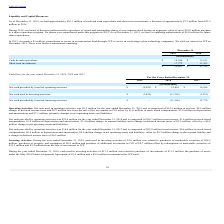From Finjan Holding's financial document, What is the respective value of purchases relating to the purchase of investments and the purchase of assets under the May 2018 Patent Assignment Agreement? The document shows two values: $11.3 million and $1.0 million. From the document: "s from the sale of the investment in JVP offset by $1.0 million in stock based compensation, $2.0 million in depreciation and amortization and $7.1 mi..." Also, What is the respective value of purchases relating to the purchase of marketable securities and purchases of property and equipment? The document shows two values: $24.5 million and $0.4 million. From the document: ".5 million, purchases of property and equipment of $0.4 million and purchase of additional investment in JVP of $0.7 million offset by redemptions of ..." Also, What is the respective value of net cash provided by operating activities relating to net income and stock-based compensation? The document shows two values: $20.7 million and $1.6 million. From the document: "8 and is comprised of $20.7 million in net income, $1.6 million in stock-based compensation, $1.8 million in depreciation and amortization, $3.4 milli..." Also, can you calculate: What is the percentage change in the net cash provided by operating activities between 2017 and 2018? To answer this question, I need to perform calculations using the financial data. The calculation is: (25,601 - 16,586)/16,586 , which equals 54.35 (percentage). This is based on the information: "sed in) operating activities $ (9,885) $ 25,601 $ 16,586 ded by (used in) operating activities $ (9,885) $ 25,601 $ 16,586..." The key data points involved are: 16,586, 25,601. Also, can you calculate: What is the average net cash provided by (used in) financing activities between 2017 and 2018? To answer this question, I need to perform calculations using the financial data. The calculation is: (12,778 +(- 21,556))/2 , which equals -4389 (in thousands). This is based on the information: "h provided by (used in) financing activities $ — (21,556) 12,778 ed by (used in) financing activities $ — (21,556) 12,778 h provided by (used in) financing activities $ — (21,556) 12,778..." The key data points involved are: 12,778, 2, 21,556. Also, can you calculate: What is the percentage change in net cash used in investing activities between 2018 and 2019? To answer this question, I need to perform calculations using the financial data. The calculation is: (3,822 - 13,203)/13,203 , which equals -71.05 (percentage). This is based on the information: "Net cash used in investing activities $ (3,822) (13,203) (1,873) Net cash used in investing activities $ (3,822) (13,203) (1,873)..." The key data points involved are: 13,203, 3,822. 